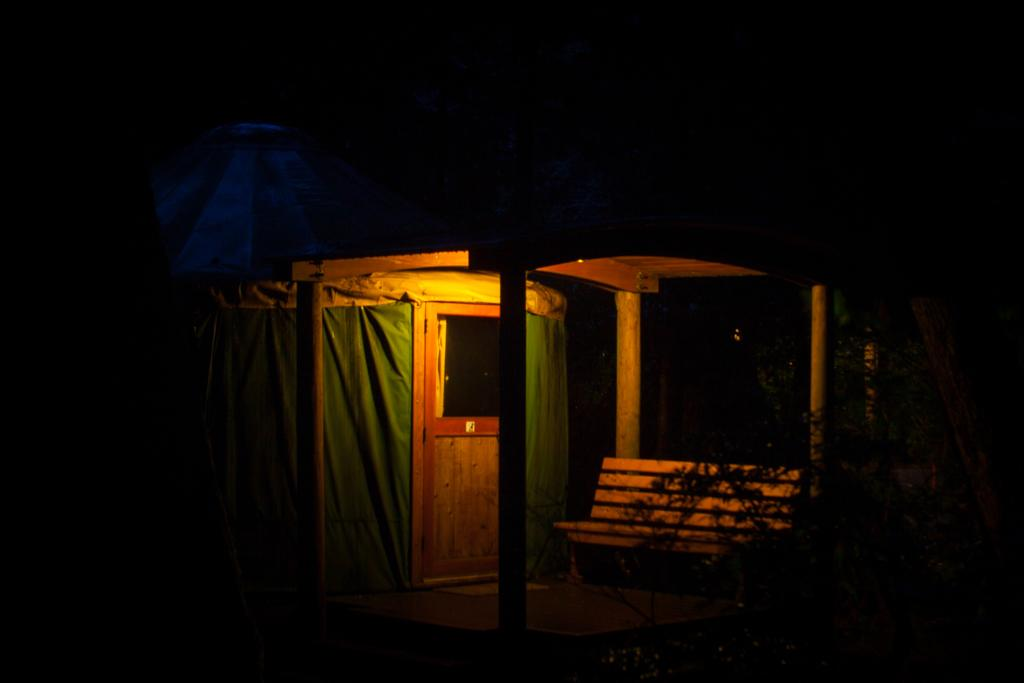What is the color of the door in the image? The door in the image is brown. What is the color of the cloth in the image? The cloth in the image is green. What type of furniture is present in the image? There is a bench in the image. What type of vegetation is visible in the image? There are plants visible in the image. What type of lighting is present in the image? There is a yellow color light in the image. How would you describe the overall lighting in the image? The background of the image is dark. Can you tell me how many combs are used to style the plants in the image? There are no combs present in the image, and the plants do not require styling. What type of railway is visible in the image? There is no railway present in the image. 